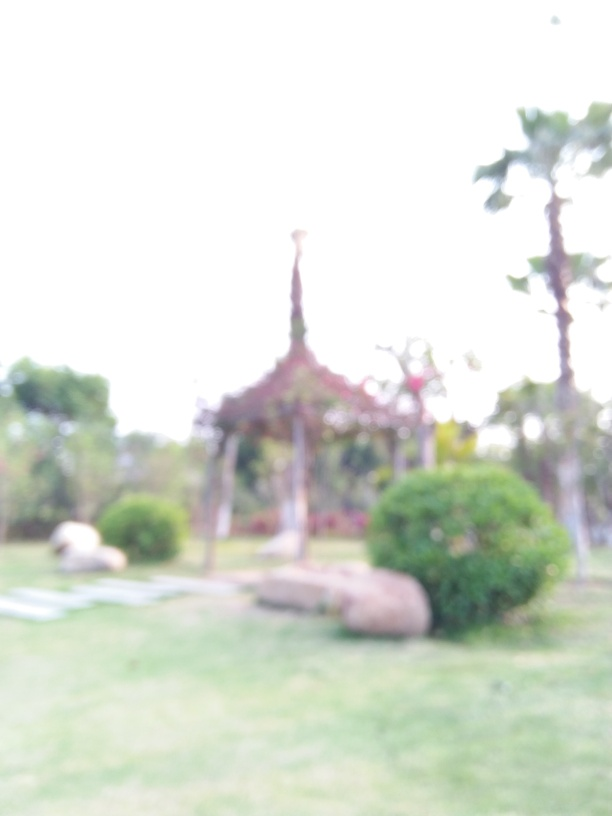Can you describe the setting or location shown in this image? The image appears to show an outdoor space that resembles a park or a garden. There seems to be a grassy area with trees around. In the center, there is a blurred structure that might be a gazebo or pavilion, which usually serves as a decorative feature and a sheltered spot to rest and enjoy the view. However, due to the lack of clarity, it is difficult to provide further details about the location. 